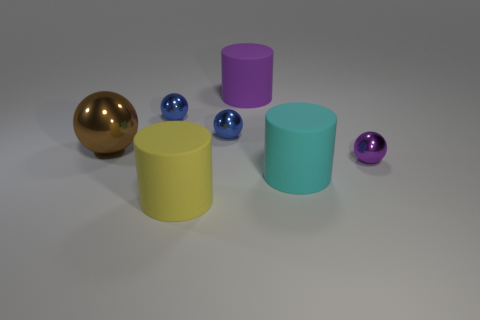Add 1 blue metal things. How many objects exist? 8 Subtract all cylinders. How many objects are left? 4 Subtract all yellow things. Subtract all matte cylinders. How many objects are left? 3 Add 1 small blue shiny spheres. How many small blue shiny spheres are left? 3 Add 6 small blue spheres. How many small blue spheres exist? 8 Subtract 0 gray cylinders. How many objects are left? 7 